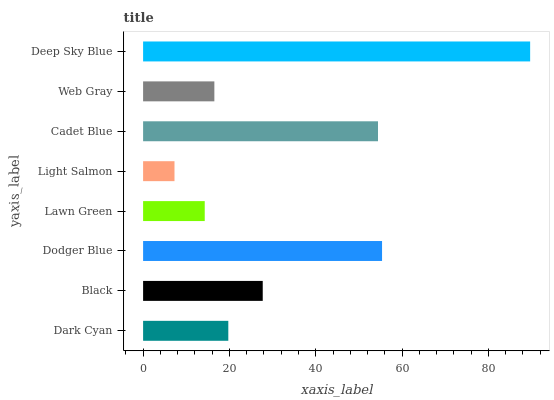Is Light Salmon the minimum?
Answer yes or no. Yes. Is Deep Sky Blue the maximum?
Answer yes or no. Yes. Is Black the minimum?
Answer yes or no. No. Is Black the maximum?
Answer yes or no. No. Is Black greater than Dark Cyan?
Answer yes or no. Yes. Is Dark Cyan less than Black?
Answer yes or no. Yes. Is Dark Cyan greater than Black?
Answer yes or no. No. Is Black less than Dark Cyan?
Answer yes or no. No. Is Black the high median?
Answer yes or no. Yes. Is Dark Cyan the low median?
Answer yes or no. Yes. Is Dodger Blue the high median?
Answer yes or no. No. Is Lawn Green the low median?
Answer yes or no. No. 